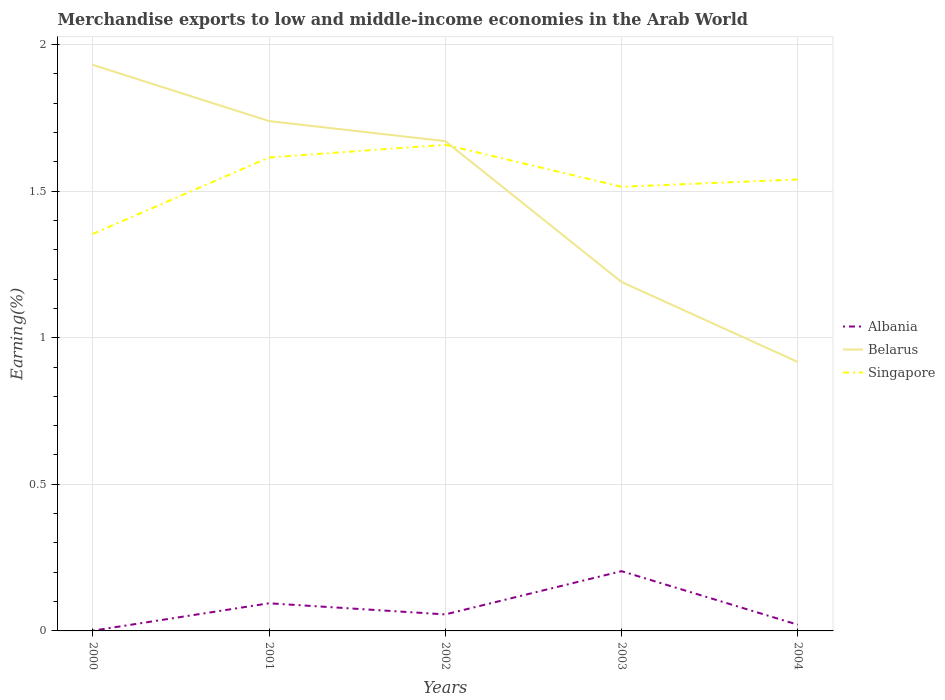How many different coloured lines are there?
Offer a terse response. 3. Is the number of lines equal to the number of legend labels?
Provide a short and direct response. Yes. Across all years, what is the maximum percentage of amount earned from merchandise exports in Singapore?
Your response must be concise. 1.35. In which year was the percentage of amount earned from merchandise exports in Albania maximum?
Your response must be concise. 2000. What is the total percentage of amount earned from merchandise exports in Belarus in the graph?
Offer a very short reply. 0.07. What is the difference between the highest and the second highest percentage of amount earned from merchandise exports in Singapore?
Offer a very short reply. 0.3. What is the difference between the highest and the lowest percentage of amount earned from merchandise exports in Albania?
Your answer should be very brief. 2. Is the percentage of amount earned from merchandise exports in Albania strictly greater than the percentage of amount earned from merchandise exports in Belarus over the years?
Your answer should be very brief. Yes. How many lines are there?
Your answer should be compact. 3. What is the difference between two consecutive major ticks on the Y-axis?
Your response must be concise. 0.5. Are the values on the major ticks of Y-axis written in scientific E-notation?
Give a very brief answer. No. Does the graph contain grids?
Your answer should be compact. Yes. Where does the legend appear in the graph?
Your answer should be very brief. Center right. How are the legend labels stacked?
Ensure brevity in your answer.  Vertical. What is the title of the graph?
Provide a short and direct response. Merchandise exports to low and middle-income economies in the Arab World. Does "Ireland" appear as one of the legend labels in the graph?
Provide a short and direct response. No. What is the label or title of the Y-axis?
Your answer should be compact. Earning(%). What is the Earning(%) in Albania in 2000?
Offer a terse response. 0. What is the Earning(%) in Belarus in 2000?
Offer a terse response. 1.93. What is the Earning(%) in Singapore in 2000?
Give a very brief answer. 1.35. What is the Earning(%) of Albania in 2001?
Offer a very short reply. 0.09. What is the Earning(%) in Belarus in 2001?
Give a very brief answer. 1.74. What is the Earning(%) of Singapore in 2001?
Your answer should be compact. 1.61. What is the Earning(%) of Albania in 2002?
Offer a very short reply. 0.06. What is the Earning(%) in Belarus in 2002?
Make the answer very short. 1.67. What is the Earning(%) of Singapore in 2002?
Provide a succinct answer. 1.66. What is the Earning(%) in Albania in 2003?
Make the answer very short. 0.2. What is the Earning(%) of Belarus in 2003?
Your answer should be very brief. 1.19. What is the Earning(%) of Singapore in 2003?
Your answer should be very brief. 1.51. What is the Earning(%) of Albania in 2004?
Your answer should be very brief. 0.02. What is the Earning(%) of Belarus in 2004?
Provide a succinct answer. 0.92. What is the Earning(%) in Singapore in 2004?
Offer a very short reply. 1.54. Across all years, what is the maximum Earning(%) in Albania?
Offer a terse response. 0.2. Across all years, what is the maximum Earning(%) in Belarus?
Offer a terse response. 1.93. Across all years, what is the maximum Earning(%) of Singapore?
Make the answer very short. 1.66. Across all years, what is the minimum Earning(%) in Albania?
Offer a very short reply. 0. Across all years, what is the minimum Earning(%) in Belarus?
Provide a succinct answer. 0.92. Across all years, what is the minimum Earning(%) of Singapore?
Your response must be concise. 1.35. What is the total Earning(%) in Albania in the graph?
Make the answer very short. 0.38. What is the total Earning(%) of Belarus in the graph?
Keep it short and to the point. 7.45. What is the total Earning(%) in Singapore in the graph?
Your answer should be very brief. 7.68. What is the difference between the Earning(%) of Albania in 2000 and that in 2001?
Provide a short and direct response. -0.09. What is the difference between the Earning(%) of Belarus in 2000 and that in 2001?
Ensure brevity in your answer.  0.19. What is the difference between the Earning(%) of Singapore in 2000 and that in 2001?
Keep it short and to the point. -0.26. What is the difference between the Earning(%) in Albania in 2000 and that in 2002?
Your answer should be compact. -0.06. What is the difference between the Earning(%) of Belarus in 2000 and that in 2002?
Provide a succinct answer. 0.26. What is the difference between the Earning(%) of Singapore in 2000 and that in 2002?
Offer a very short reply. -0.3. What is the difference between the Earning(%) of Albania in 2000 and that in 2003?
Keep it short and to the point. -0.2. What is the difference between the Earning(%) in Belarus in 2000 and that in 2003?
Your answer should be compact. 0.74. What is the difference between the Earning(%) in Singapore in 2000 and that in 2003?
Your answer should be very brief. -0.16. What is the difference between the Earning(%) of Albania in 2000 and that in 2004?
Ensure brevity in your answer.  -0.02. What is the difference between the Earning(%) of Belarus in 2000 and that in 2004?
Provide a succinct answer. 1.01. What is the difference between the Earning(%) in Singapore in 2000 and that in 2004?
Your answer should be very brief. -0.19. What is the difference between the Earning(%) of Albania in 2001 and that in 2002?
Ensure brevity in your answer.  0.04. What is the difference between the Earning(%) in Belarus in 2001 and that in 2002?
Offer a terse response. 0.07. What is the difference between the Earning(%) in Singapore in 2001 and that in 2002?
Provide a short and direct response. -0.04. What is the difference between the Earning(%) in Albania in 2001 and that in 2003?
Give a very brief answer. -0.11. What is the difference between the Earning(%) of Belarus in 2001 and that in 2003?
Your answer should be compact. 0.55. What is the difference between the Earning(%) in Singapore in 2001 and that in 2003?
Ensure brevity in your answer.  0.1. What is the difference between the Earning(%) in Albania in 2001 and that in 2004?
Your answer should be compact. 0.07. What is the difference between the Earning(%) of Belarus in 2001 and that in 2004?
Your answer should be very brief. 0.82. What is the difference between the Earning(%) of Singapore in 2001 and that in 2004?
Offer a terse response. 0.07. What is the difference between the Earning(%) of Albania in 2002 and that in 2003?
Provide a short and direct response. -0.15. What is the difference between the Earning(%) of Belarus in 2002 and that in 2003?
Provide a succinct answer. 0.48. What is the difference between the Earning(%) in Singapore in 2002 and that in 2003?
Offer a very short reply. 0.14. What is the difference between the Earning(%) of Albania in 2002 and that in 2004?
Provide a short and direct response. 0.04. What is the difference between the Earning(%) of Belarus in 2002 and that in 2004?
Your answer should be very brief. 0.75. What is the difference between the Earning(%) of Singapore in 2002 and that in 2004?
Your answer should be very brief. 0.12. What is the difference between the Earning(%) in Albania in 2003 and that in 2004?
Your answer should be compact. 0.18. What is the difference between the Earning(%) in Belarus in 2003 and that in 2004?
Your answer should be very brief. 0.27. What is the difference between the Earning(%) of Singapore in 2003 and that in 2004?
Your response must be concise. -0.02. What is the difference between the Earning(%) of Albania in 2000 and the Earning(%) of Belarus in 2001?
Provide a succinct answer. -1.74. What is the difference between the Earning(%) in Albania in 2000 and the Earning(%) in Singapore in 2001?
Your answer should be very brief. -1.61. What is the difference between the Earning(%) in Belarus in 2000 and the Earning(%) in Singapore in 2001?
Your answer should be very brief. 0.32. What is the difference between the Earning(%) in Albania in 2000 and the Earning(%) in Belarus in 2002?
Your response must be concise. -1.67. What is the difference between the Earning(%) of Albania in 2000 and the Earning(%) of Singapore in 2002?
Provide a succinct answer. -1.66. What is the difference between the Earning(%) in Belarus in 2000 and the Earning(%) in Singapore in 2002?
Give a very brief answer. 0.27. What is the difference between the Earning(%) in Albania in 2000 and the Earning(%) in Belarus in 2003?
Offer a very short reply. -1.19. What is the difference between the Earning(%) in Albania in 2000 and the Earning(%) in Singapore in 2003?
Offer a very short reply. -1.51. What is the difference between the Earning(%) in Belarus in 2000 and the Earning(%) in Singapore in 2003?
Give a very brief answer. 0.42. What is the difference between the Earning(%) in Albania in 2000 and the Earning(%) in Belarus in 2004?
Offer a very short reply. -0.92. What is the difference between the Earning(%) of Albania in 2000 and the Earning(%) of Singapore in 2004?
Provide a short and direct response. -1.54. What is the difference between the Earning(%) in Belarus in 2000 and the Earning(%) in Singapore in 2004?
Make the answer very short. 0.39. What is the difference between the Earning(%) of Albania in 2001 and the Earning(%) of Belarus in 2002?
Make the answer very short. -1.58. What is the difference between the Earning(%) of Albania in 2001 and the Earning(%) of Singapore in 2002?
Your answer should be very brief. -1.56. What is the difference between the Earning(%) in Belarus in 2001 and the Earning(%) in Singapore in 2002?
Your answer should be very brief. 0.08. What is the difference between the Earning(%) in Albania in 2001 and the Earning(%) in Belarus in 2003?
Offer a very short reply. -1.1. What is the difference between the Earning(%) of Albania in 2001 and the Earning(%) of Singapore in 2003?
Your answer should be compact. -1.42. What is the difference between the Earning(%) of Belarus in 2001 and the Earning(%) of Singapore in 2003?
Your answer should be compact. 0.22. What is the difference between the Earning(%) in Albania in 2001 and the Earning(%) in Belarus in 2004?
Make the answer very short. -0.82. What is the difference between the Earning(%) in Albania in 2001 and the Earning(%) in Singapore in 2004?
Keep it short and to the point. -1.45. What is the difference between the Earning(%) in Belarus in 2001 and the Earning(%) in Singapore in 2004?
Offer a very short reply. 0.2. What is the difference between the Earning(%) in Albania in 2002 and the Earning(%) in Belarus in 2003?
Provide a short and direct response. -1.13. What is the difference between the Earning(%) in Albania in 2002 and the Earning(%) in Singapore in 2003?
Your answer should be very brief. -1.46. What is the difference between the Earning(%) of Belarus in 2002 and the Earning(%) of Singapore in 2003?
Offer a terse response. 0.16. What is the difference between the Earning(%) in Albania in 2002 and the Earning(%) in Belarus in 2004?
Provide a succinct answer. -0.86. What is the difference between the Earning(%) in Albania in 2002 and the Earning(%) in Singapore in 2004?
Give a very brief answer. -1.48. What is the difference between the Earning(%) in Belarus in 2002 and the Earning(%) in Singapore in 2004?
Your response must be concise. 0.13. What is the difference between the Earning(%) in Albania in 2003 and the Earning(%) in Belarus in 2004?
Ensure brevity in your answer.  -0.71. What is the difference between the Earning(%) in Albania in 2003 and the Earning(%) in Singapore in 2004?
Your answer should be very brief. -1.34. What is the difference between the Earning(%) in Belarus in 2003 and the Earning(%) in Singapore in 2004?
Make the answer very short. -0.35. What is the average Earning(%) in Albania per year?
Offer a terse response. 0.08. What is the average Earning(%) of Belarus per year?
Make the answer very short. 1.49. What is the average Earning(%) of Singapore per year?
Give a very brief answer. 1.54. In the year 2000, what is the difference between the Earning(%) of Albania and Earning(%) of Belarus?
Your answer should be very brief. -1.93. In the year 2000, what is the difference between the Earning(%) in Albania and Earning(%) in Singapore?
Keep it short and to the point. -1.35. In the year 2000, what is the difference between the Earning(%) in Belarus and Earning(%) in Singapore?
Make the answer very short. 0.58. In the year 2001, what is the difference between the Earning(%) of Albania and Earning(%) of Belarus?
Give a very brief answer. -1.64. In the year 2001, what is the difference between the Earning(%) in Albania and Earning(%) in Singapore?
Ensure brevity in your answer.  -1.52. In the year 2001, what is the difference between the Earning(%) of Belarus and Earning(%) of Singapore?
Give a very brief answer. 0.12. In the year 2002, what is the difference between the Earning(%) of Albania and Earning(%) of Belarus?
Give a very brief answer. -1.61. In the year 2002, what is the difference between the Earning(%) of Albania and Earning(%) of Singapore?
Your answer should be compact. -1.6. In the year 2002, what is the difference between the Earning(%) of Belarus and Earning(%) of Singapore?
Provide a short and direct response. 0.01. In the year 2003, what is the difference between the Earning(%) of Albania and Earning(%) of Belarus?
Provide a succinct answer. -0.99. In the year 2003, what is the difference between the Earning(%) in Albania and Earning(%) in Singapore?
Ensure brevity in your answer.  -1.31. In the year 2003, what is the difference between the Earning(%) in Belarus and Earning(%) in Singapore?
Your answer should be compact. -0.32. In the year 2004, what is the difference between the Earning(%) of Albania and Earning(%) of Belarus?
Ensure brevity in your answer.  -0.9. In the year 2004, what is the difference between the Earning(%) of Albania and Earning(%) of Singapore?
Offer a very short reply. -1.52. In the year 2004, what is the difference between the Earning(%) of Belarus and Earning(%) of Singapore?
Make the answer very short. -0.62. What is the ratio of the Earning(%) of Albania in 2000 to that in 2001?
Offer a very short reply. 0.01. What is the ratio of the Earning(%) in Belarus in 2000 to that in 2001?
Make the answer very short. 1.11. What is the ratio of the Earning(%) in Singapore in 2000 to that in 2001?
Give a very brief answer. 0.84. What is the ratio of the Earning(%) of Albania in 2000 to that in 2002?
Your response must be concise. 0.02. What is the ratio of the Earning(%) of Belarus in 2000 to that in 2002?
Provide a succinct answer. 1.16. What is the ratio of the Earning(%) in Singapore in 2000 to that in 2002?
Provide a short and direct response. 0.82. What is the ratio of the Earning(%) of Albania in 2000 to that in 2003?
Give a very brief answer. 0. What is the ratio of the Earning(%) in Belarus in 2000 to that in 2003?
Offer a terse response. 1.62. What is the ratio of the Earning(%) of Singapore in 2000 to that in 2003?
Ensure brevity in your answer.  0.89. What is the ratio of the Earning(%) of Albania in 2000 to that in 2004?
Your answer should be very brief. 0.04. What is the ratio of the Earning(%) of Belarus in 2000 to that in 2004?
Keep it short and to the point. 2.1. What is the ratio of the Earning(%) of Singapore in 2000 to that in 2004?
Your response must be concise. 0.88. What is the ratio of the Earning(%) of Albania in 2001 to that in 2002?
Give a very brief answer. 1.67. What is the ratio of the Earning(%) in Belarus in 2001 to that in 2002?
Your response must be concise. 1.04. What is the ratio of the Earning(%) of Singapore in 2001 to that in 2002?
Provide a short and direct response. 0.97. What is the ratio of the Earning(%) in Albania in 2001 to that in 2003?
Your answer should be compact. 0.46. What is the ratio of the Earning(%) in Belarus in 2001 to that in 2003?
Make the answer very short. 1.46. What is the ratio of the Earning(%) in Singapore in 2001 to that in 2003?
Offer a terse response. 1.07. What is the ratio of the Earning(%) of Albania in 2001 to that in 2004?
Your answer should be compact. 4.44. What is the ratio of the Earning(%) in Belarus in 2001 to that in 2004?
Your response must be concise. 1.9. What is the ratio of the Earning(%) of Singapore in 2001 to that in 2004?
Give a very brief answer. 1.05. What is the ratio of the Earning(%) in Albania in 2002 to that in 2003?
Ensure brevity in your answer.  0.28. What is the ratio of the Earning(%) in Belarus in 2002 to that in 2003?
Your response must be concise. 1.4. What is the ratio of the Earning(%) in Singapore in 2002 to that in 2003?
Make the answer very short. 1.09. What is the ratio of the Earning(%) in Albania in 2002 to that in 2004?
Your response must be concise. 2.66. What is the ratio of the Earning(%) of Belarus in 2002 to that in 2004?
Your answer should be compact. 1.82. What is the ratio of the Earning(%) of Singapore in 2002 to that in 2004?
Provide a succinct answer. 1.08. What is the ratio of the Earning(%) of Albania in 2003 to that in 2004?
Ensure brevity in your answer.  9.61. What is the ratio of the Earning(%) of Belarus in 2003 to that in 2004?
Keep it short and to the point. 1.3. What is the ratio of the Earning(%) in Singapore in 2003 to that in 2004?
Offer a terse response. 0.98. What is the difference between the highest and the second highest Earning(%) of Albania?
Ensure brevity in your answer.  0.11. What is the difference between the highest and the second highest Earning(%) in Belarus?
Provide a short and direct response. 0.19. What is the difference between the highest and the second highest Earning(%) in Singapore?
Offer a very short reply. 0.04. What is the difference between the highest and the lowest Earning(%) of Albania?
Provide a short and direct response. 0.2. What is the difference between the highest and the lowest Earning(%) of Belarus?
Give a very brief answer. 1.01. What is the difference between the highest and the lowest Earning(%) in Singapore?
Your response must be concise. 0.3. 